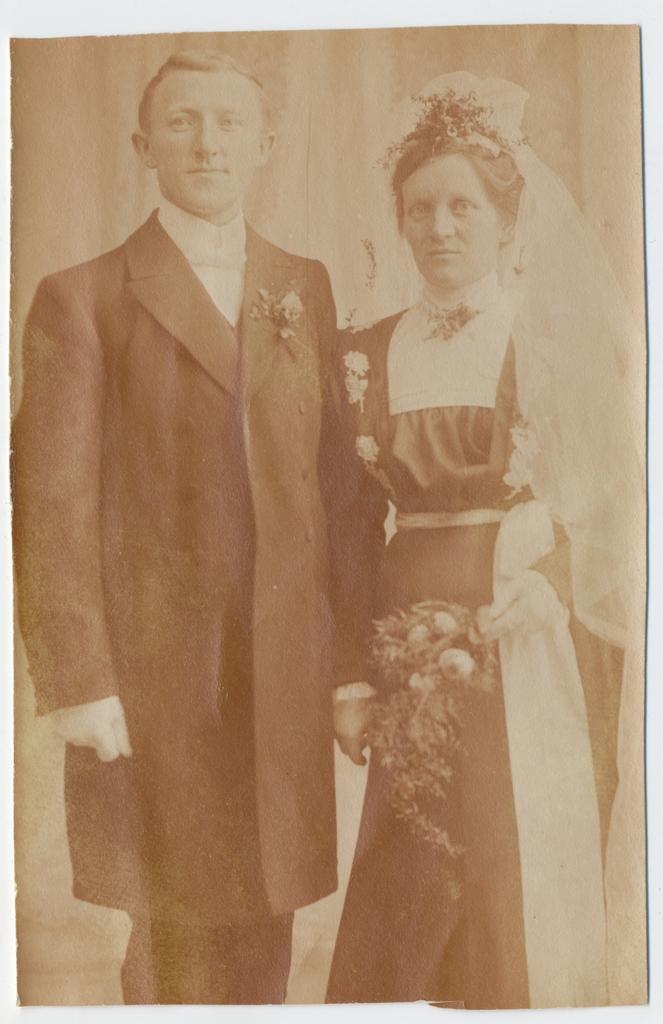Describe this image in one or two sentences. In this picture we can see a man is standing. And a lady is standing and holding a flowers on her hand. 